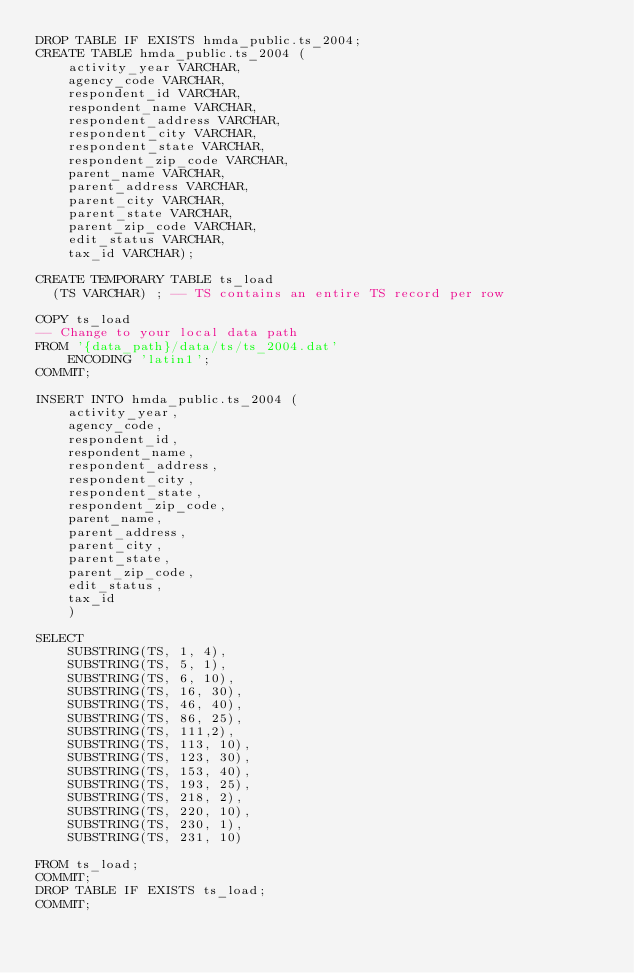Convert code to text. <code><loc_0><loc_0><loc_500><loc_500><_SQL_>DROP TABLE IF EXISTS hmda_public.ts_2004;
CREATE TABLE hmda_public.ts_2004 (
	activity_year VARCHAR,
	agency_code VARCHAR,
	respondent_id VARCHAR,
	respondent_name VARCHAR,
	respondent_address VARCHAR,
	respondent_city VARCHAR,
	respondent_state VARCHAR,
	respondent_zip_code VARCHAR,
	parent_name VARCHAR,
	parent_address VARCHAR,
	parent_city VARCHAR,
	parent_state VARCHAR,
	parent_zip_code VARCHAR,
	edit_status VARCHAR,
	tax_id VARCHAR);

CREATE TEMPORARY TABLE ts_load 
  (TS VARCHAR) ; -- TS contains an entire TS record per row

COPY ts_load 
-- Change to your local data path
FROM '{data_path}/data/ts/ts_2004.dat' 
    ENCODING 'latin1';
COMMIT;

INSERT INTO hmda_public.ts_2004 (
	activity_year,
	agency_code,
	respondent_id,
	respondent_name,
	respondent_address,
	respondent_city,
	respondent_state,
	respondent_zip_code,
	parent_name,
	parent_address,
	parent_city,
	parent_state,
	parent_zip_code,
	edit_status,
	tax_id
	)

SELECT 
	SUBSTRING(TS, 1, 4),
	SUBSTRING(TS, 5, 1),
	SUBSTRING(TS, 6, 10),
	SUBSTRING(TS, 16, 30),
	SUBSTRING(TS, 46, 40),
	SUBSTRING(TS, 86, 25),
	SUBSTRING(TS, 111,2),
	SUBSTRING(TS, 113, 10),
	SUBSTRING(TS, 123, 30),
	SUBSTRING(TS, 153, 40),
	SUBSTRING(TS, 193, 25),
	SUBSTRING(TS, 218, 2),
	SUBSTRING(TS, 220, 10),
	SUBSTRING(TS, 230, 1),
	SUBSTRING(TS, 231, 10)
	
FROM ts_load;
COMMIT;
DROP TABLE IF EXISTS ts_load; 
COMMIT;
</code> 